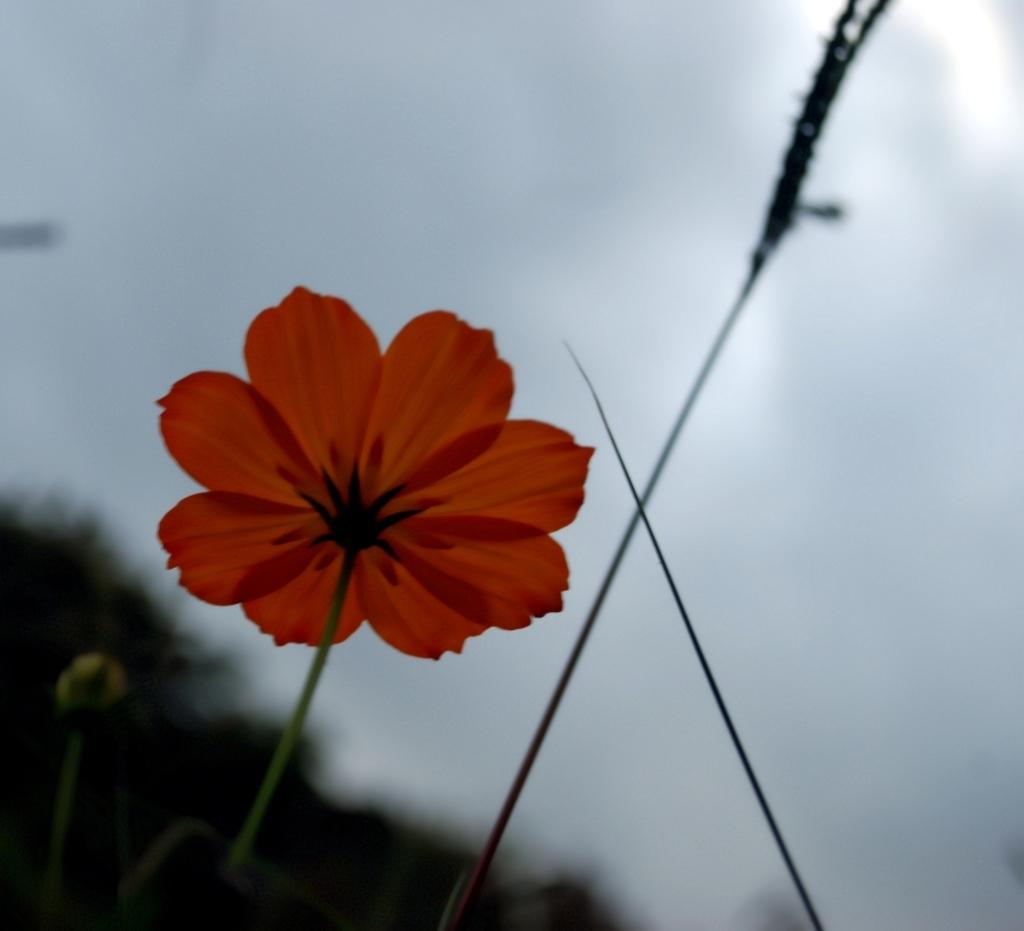What is the main subject of the image? There is a flower in the image. Can you describe the flower in more detail? The flower has a stem. What else can be seen near the flower? There is a bud beside the flower. What is visible at the top of the image? The sky is visible at the top of the image. How would you describe the background of the image? The background of the image is blurry. How many pizzas are being served on the beach in the image? There are no pizzas or beach present in the image; it features a flower with a blurry background. What statement does the flower make in the image? The flower does not make a statement in the image; it is simply a flower with a stem and a bud beside it. 